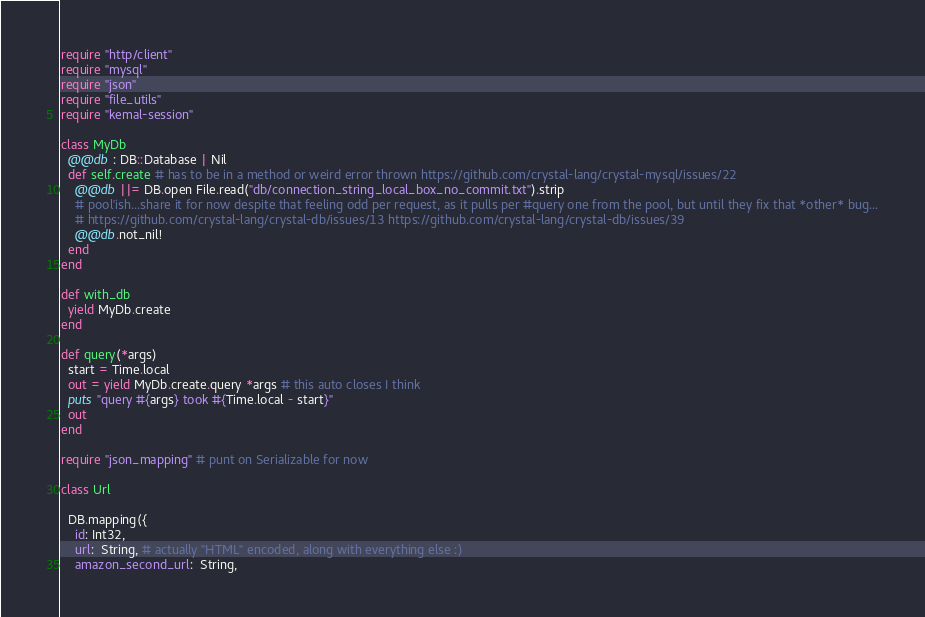<code> <loc_0><loc_0><loc_500><loc_500><_Crystal_>require "http/client"
require "mysql"
require "json"
require "file_utils"
require "kemal-session"

class MyDb
  @@db : DB::Database | Nil
  def self.create # has to be in a method or weird error thrown https://github.com/crystal-lang/crystal-mysql/issues/22
    @@db ||= DB.open File.read("db/connection_string_local_box_no_commit.txt").strip
    # pool'ish...share it for now despite that feeling odd per request, as it pulls per #query one from the pool, but until they fix that *other* bug...
    # https://github.com/crystal-lang/crystal-db/issues/13 https://github.com/crystal-lang/crystal-db/issues/39
    @@db.not_nil!
  end
end

def with_db
  yield MyDb.create
end

def query(*args)
  start = Time.local
  out = yield MyDb.create.query *args # this auto closes I think
  puts "query #{args} took #{Time.local - start}"
  out
end

require "json_mapping" # punt on Serializable for now

class Url
  
  DB.mapping({
    id: Int32,
    url:  String, # actually "HTML" encoded, along with everything else :)
    amazon_second_url:  String,</code> 